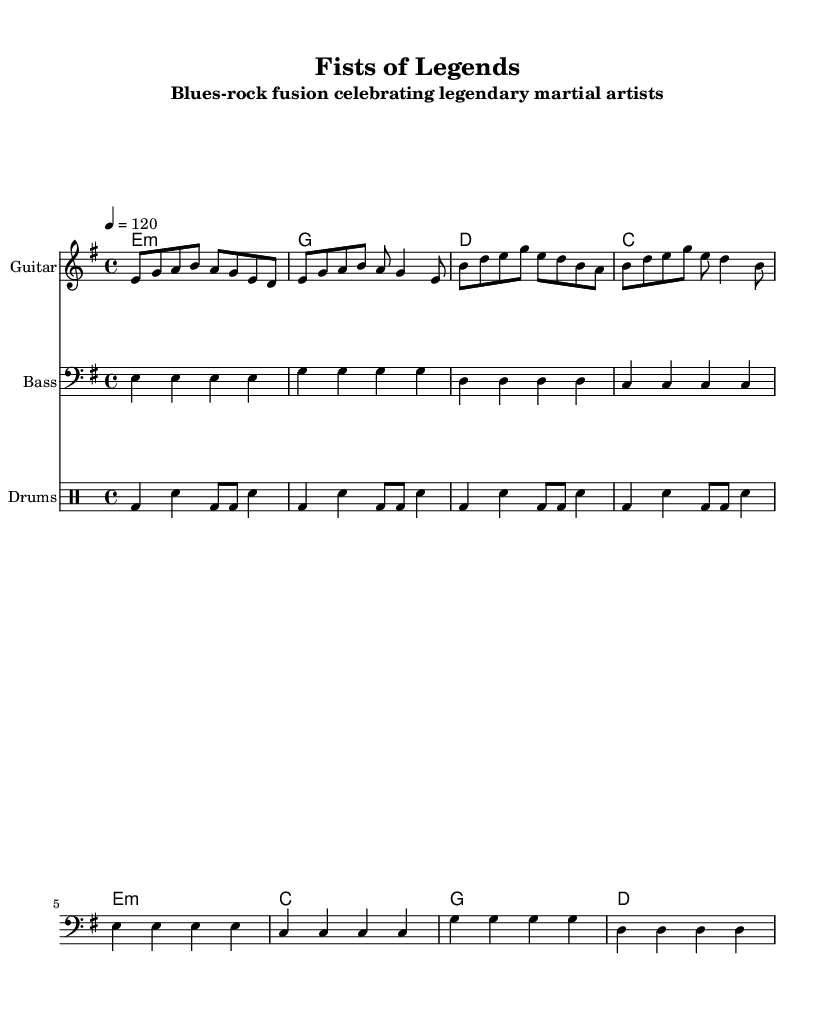What is the key signature of this music? The key signature is E minor, which contains one sharp (F#). In the music sheet, this is indicated by the presence of one sharp in the key signature section.
Answer: E minor What is the time signature of this music? The time signature is 4/4, which indicates that there are four beats in each measure and the quarter note gets one beat. This is found at the beginning of the sheet music in the time signature indicator.
Answer: 4/4 What is the tempo marking of the music? The tempo marking is indicated as "4 = 120," meaning there are 120 beats per minute, with the quarter note being the beat. This is explicitly stated at the top of the score under the tempo indication.
Answer: 120 How many measures are in the verse section? The verse section contains 8 measures. By counting the measures in both the guitar and bass parts, one can tally them up noting the repeated parts accordingly.
Answer: 8 What are the two martial arts mentioned in the lyrics? The two martial arts mentioned are Wing Chun and Samurai, as noted in the lyrics of the verse section which explicitly mentions these styles.
Answer: Wing Chun, Samurai Which instrument plays the primary melodic line in the verse? The guitar plays the primary melodic line in the verse as indicated by the staff labeled "Guitar" where the verse melody is written.
Answer: Guitar What overall theme is represented in this piece of music? The overall theme is the celebration of legendary martial artists through electric blues and blues-rock fusion, as indicated in the title and lyrics.
Answer: Legendary martial artists 